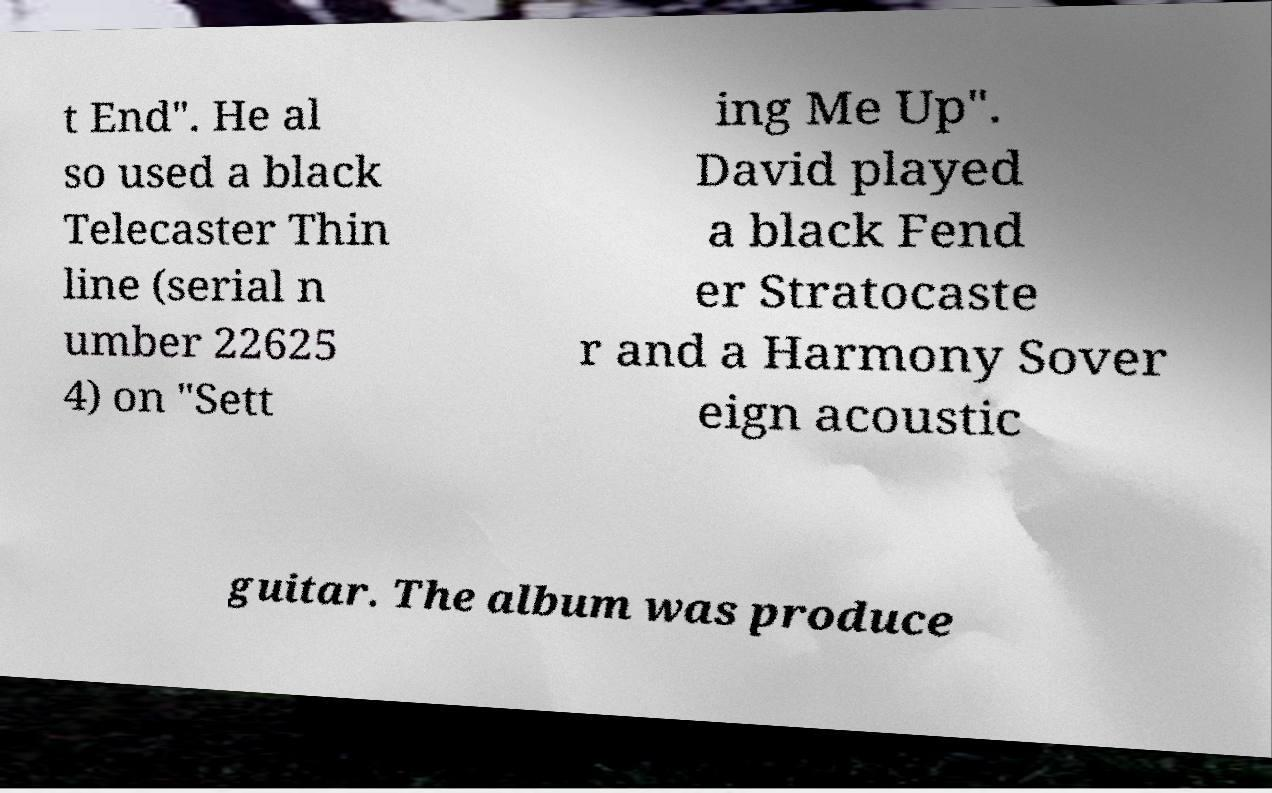Could you assist in decoding the text presented in this image and type it out clearly? t End". He al so used a black Telecaster Thin line (serial n umber 22625 4) on "Sett ing Me Up". David played a black Fend er Stratocaste r and a Harmony Sover eign acoustic guitar. The album was produce 